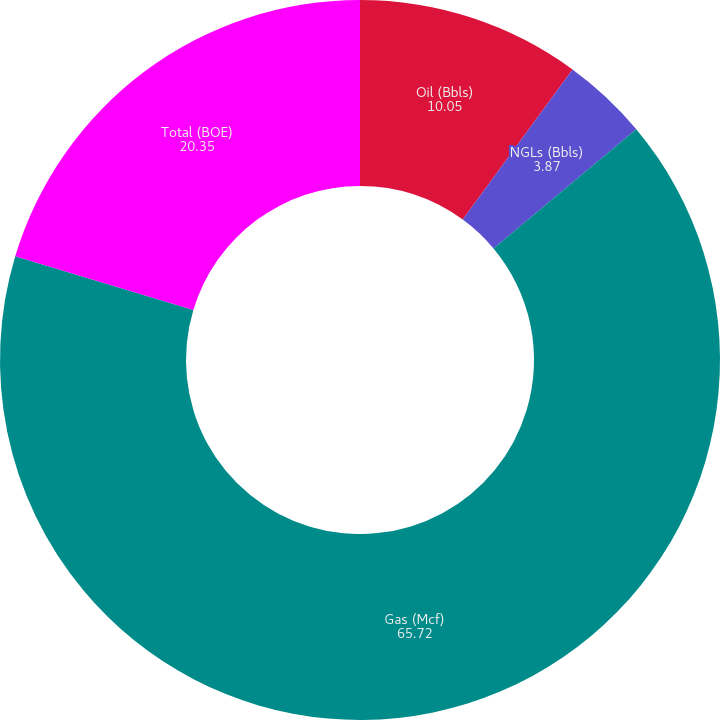<chart> <loc_0><loc_0><loc_500><loc_500><pie_chart><fcel>Oil (Bbls)<fcel>NGLs (Bbls)<fcel>Gas (Mcf)<fcel>Total (BOE)<nl><fcel>10.05%<fcel>3.87%<fcel>65.72%<fcel>20.35%<nl></chart> 